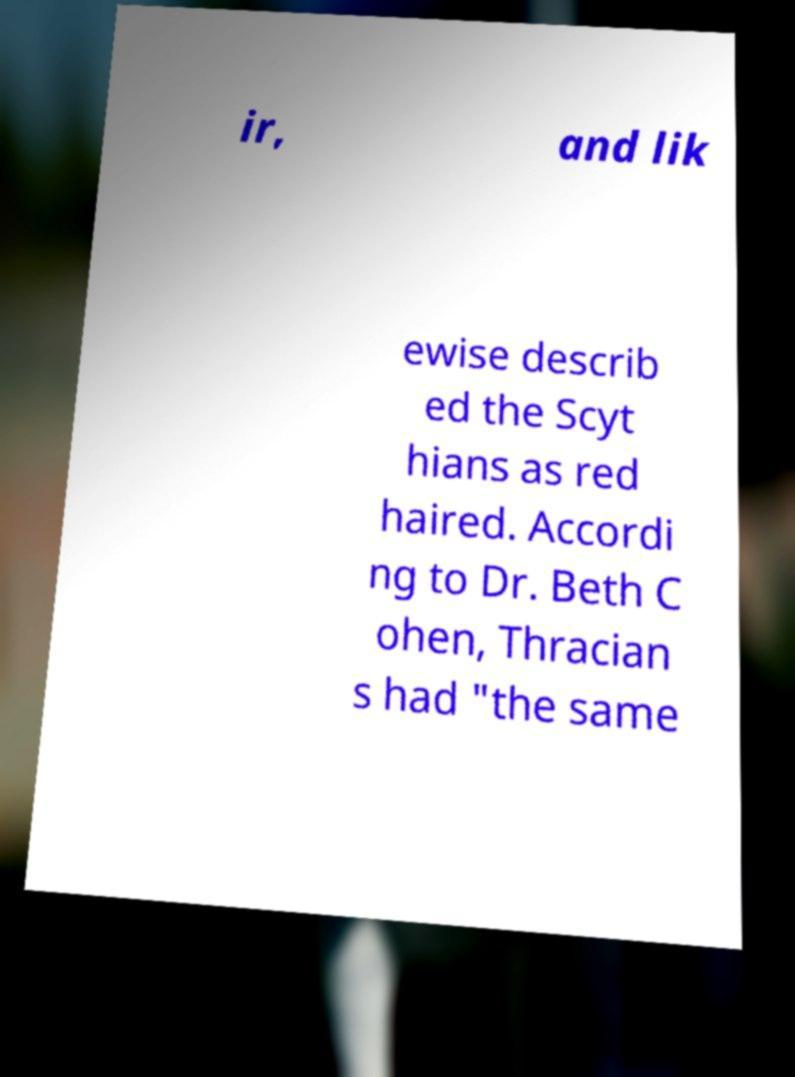What messages or text are displayed in this image? I need them in a readable, typed format. ir, and lik ewise describ ed the Scyt hians as red haired. Accordi ng to Dr. Beth C ohen, Thracian s had "the same 